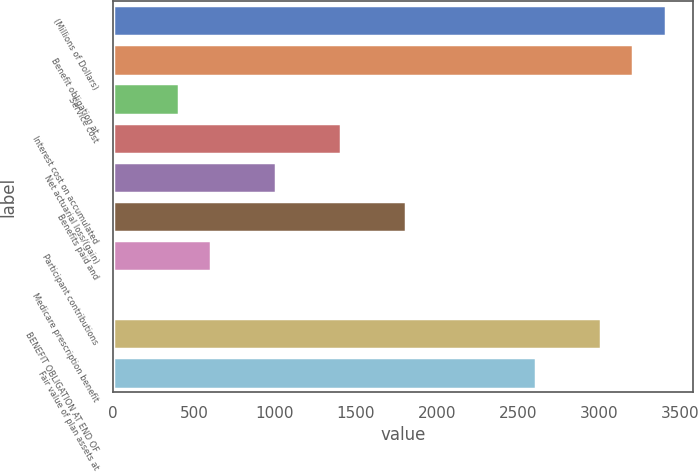<chart> <loc_0><loc_0><loc_500><loc_500><bar_chart><fcel>(Millions of Dollars)<fcel>Benefit obligation at<fcel>Service cost<fcel>Interest cost on accumulated<fcel>Net actuarial loss/(gain)<fcel>Benefits paid and<fcel>Participant contributions<fcel>Medicare prescription benefit<fcel>BENEFIT OBLIGATION AT END OF<fcel>Fair value of plan assets at<nl><fcel>3412.1<fcel>3211.8<fcel>407.6<fcel>1409.1<fcel>1008.5<fcel>1809.7<fcel>607.9<fcel>7<fcel>3011.5<fcel>2610.9<nl></chart> 